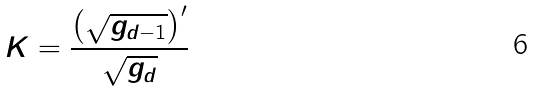<formula> <loc_0><loc_0><loc_500><loc_500>K = \frac { \left ( \sqrt { g _ { d - 1 } } \right ) ^ { \prime } } { \sqrt { g _ { d } } }</formula> 